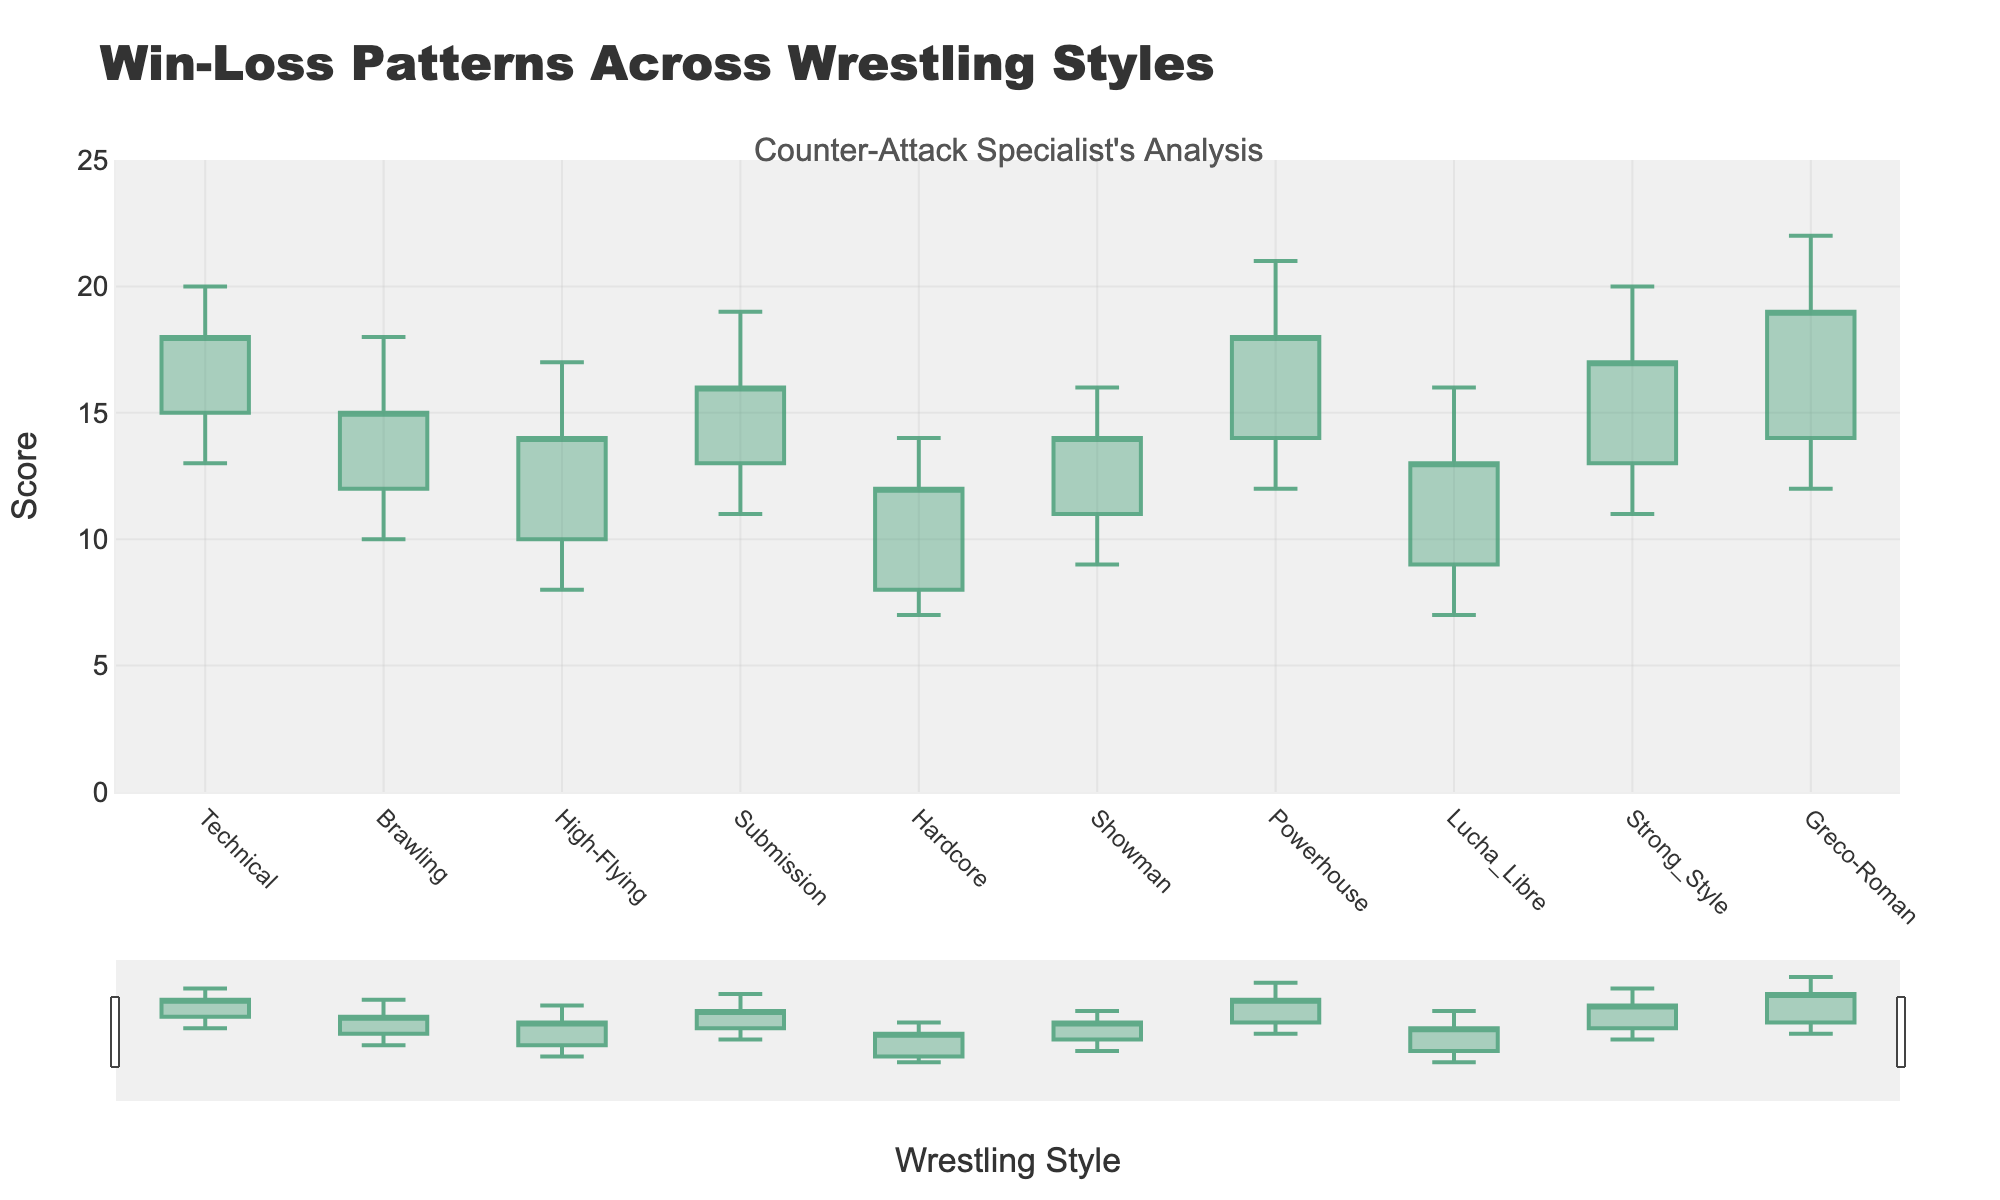Which wrestling style has the highest closing score? From the candlestick plot, identify the highest point in the 'Close' data; here, Greco-Roman has the highest closing score of 19.
Answer: Greco-Roman What is the difference between the highest and lowest scores for the Technical style? For Technical style, the highest score is 20, and the lowest score is 13, so the difference is 20 - 13.
Answer: 7 Which wrestling style had the largest range between high and low scores? Identify the range (High - Low) for each style; Greco-Roman has the highest range (22 - 12 = 10).
Answer: Greco-Roman Which wrestling style showed no change in its closing score compared to the open score? Compare 'Open' and 'Close' values for each style; none of the wrestling styles has the same open and close values, indicating change for all.
Answer: None How many wrestling styles have a closing score greater than their opening score? Compare 'Close' with 'Open' for all styles; count the number of styles where 'Close' > 'Open' (Technical, Brawling, High-Flying, Submission, Powerhouse, Strong Style, Greco-Roman).
Answer: 7 For Brawling, what is the sum of the open and close scores? Sum of 'Open' and 'Close' for Brawling is 12 + 15.
Answer: 27 Which style experienced the highest high score overall? Identify the highest 'High' score from the chart; Greco-Roman has the highest high score of 22.
Answer: Greco-Roman In terms of closing scores, which style performed better: Technical or Powerhouse? Compare the 'Close' values of Technical (18) and Powerhouse (18); both have the same closing score.
Answer: Both are equal What is the average closing score of all the wrestling styles? Sum of all 'Close' scores (18 + 15 + 14 + 16 + 12 + 14 + 18 + 13 + 17 + 19) divided by the number of styles (10). The calculation is (156 / 10).
Answer: 15.6 Which wrestling style had the most similar performance in terms of its open and close scores? Calculate the absolute difference between 'Open' and 'Close' for each style and find the smallest; Brawling has a difference of 3 (15 - 12).
Answer: Brawling 